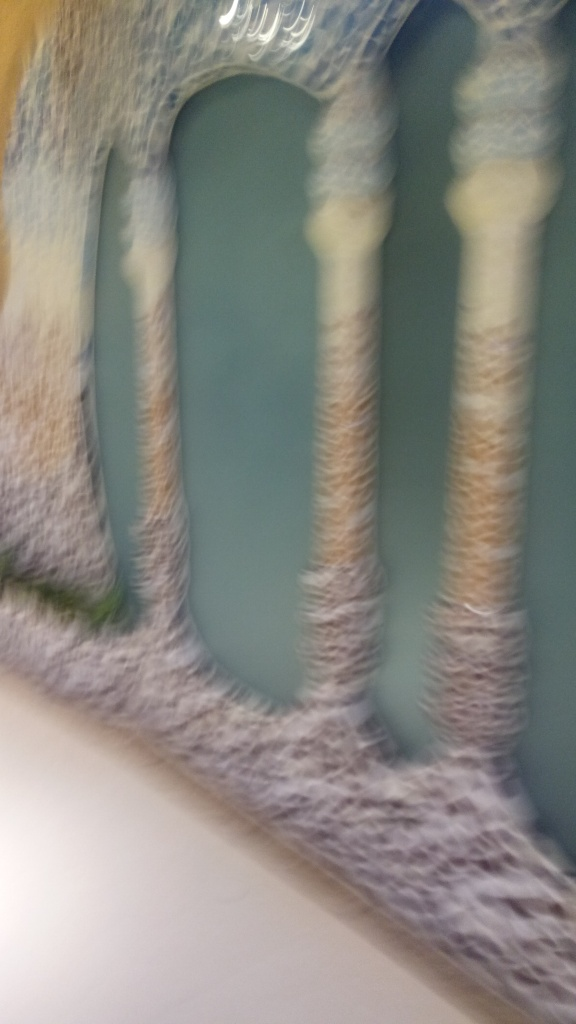Can you describe what might be causing the blurriness in this photo? The blurriness could be due to several factors, such as camera shake, a slow shutter speed not suitable for the lighting conditions, or an improper focus setting. It might also result from taking the picture while in motion, or if the subject itself was moving rapidly at the time of capture. 